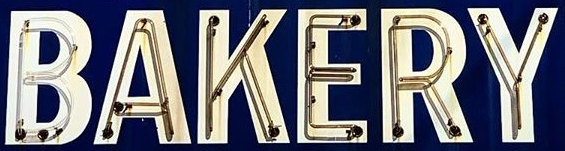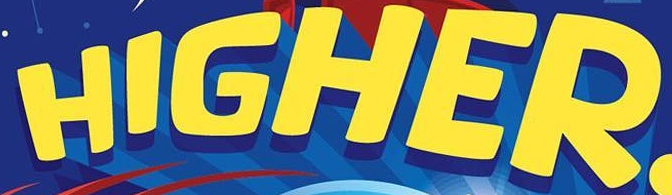What words can you see in these images in sequence, separated by a semicolon? BAKERY; HIGHER 